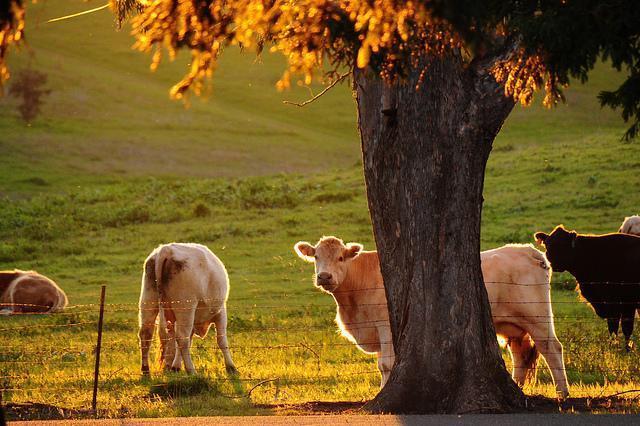How many cows are in the field?
Give a very brief answer. 5. How many cows are in the photo?
Give a very brief answer. 4. 